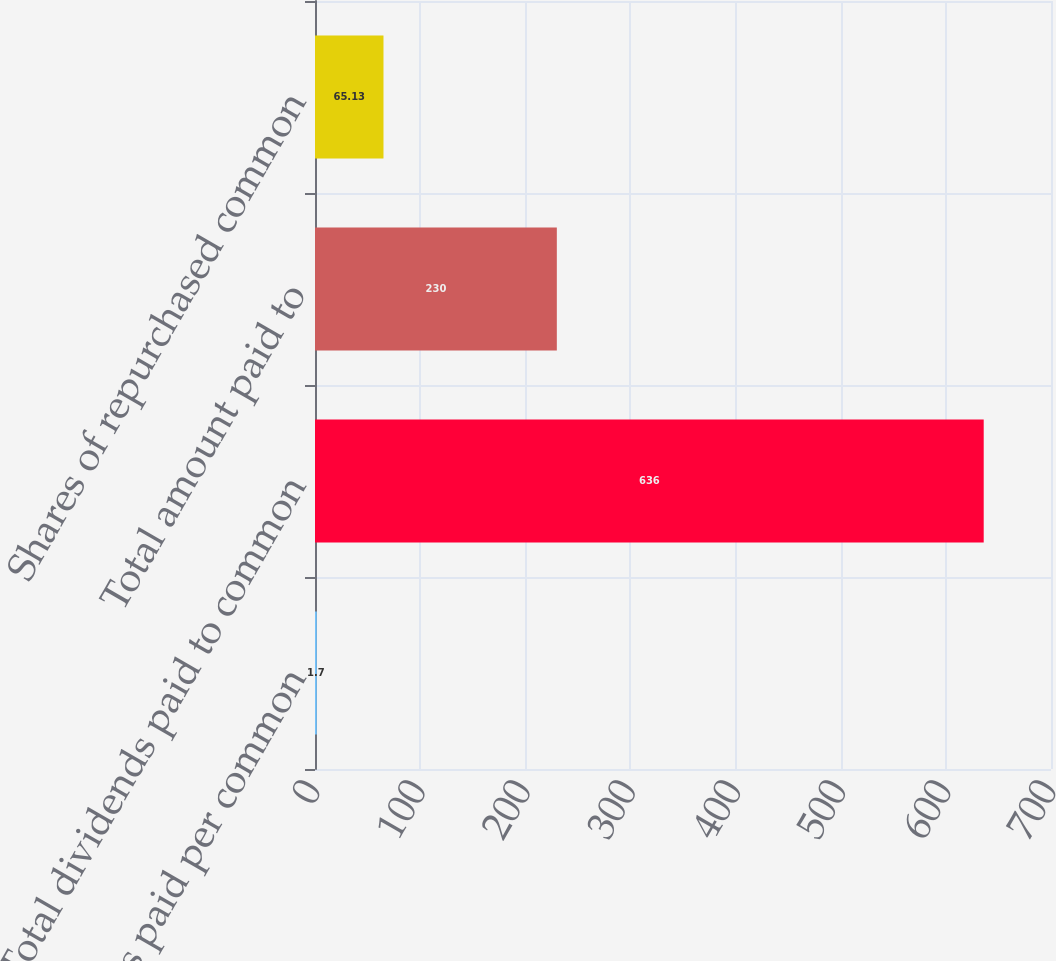Convert chart. <chart><loc_0><loc_0><loc_500><loc_500><bar_chart><fcel>Dividends paid per common<fcel>Total dividends paid to common<fcel>Total amount paid to<fcel>Shares of repurchased common<nl><fcel>1.7<fcel>636<fcel>230<fcel>65.13<nl></chart> 